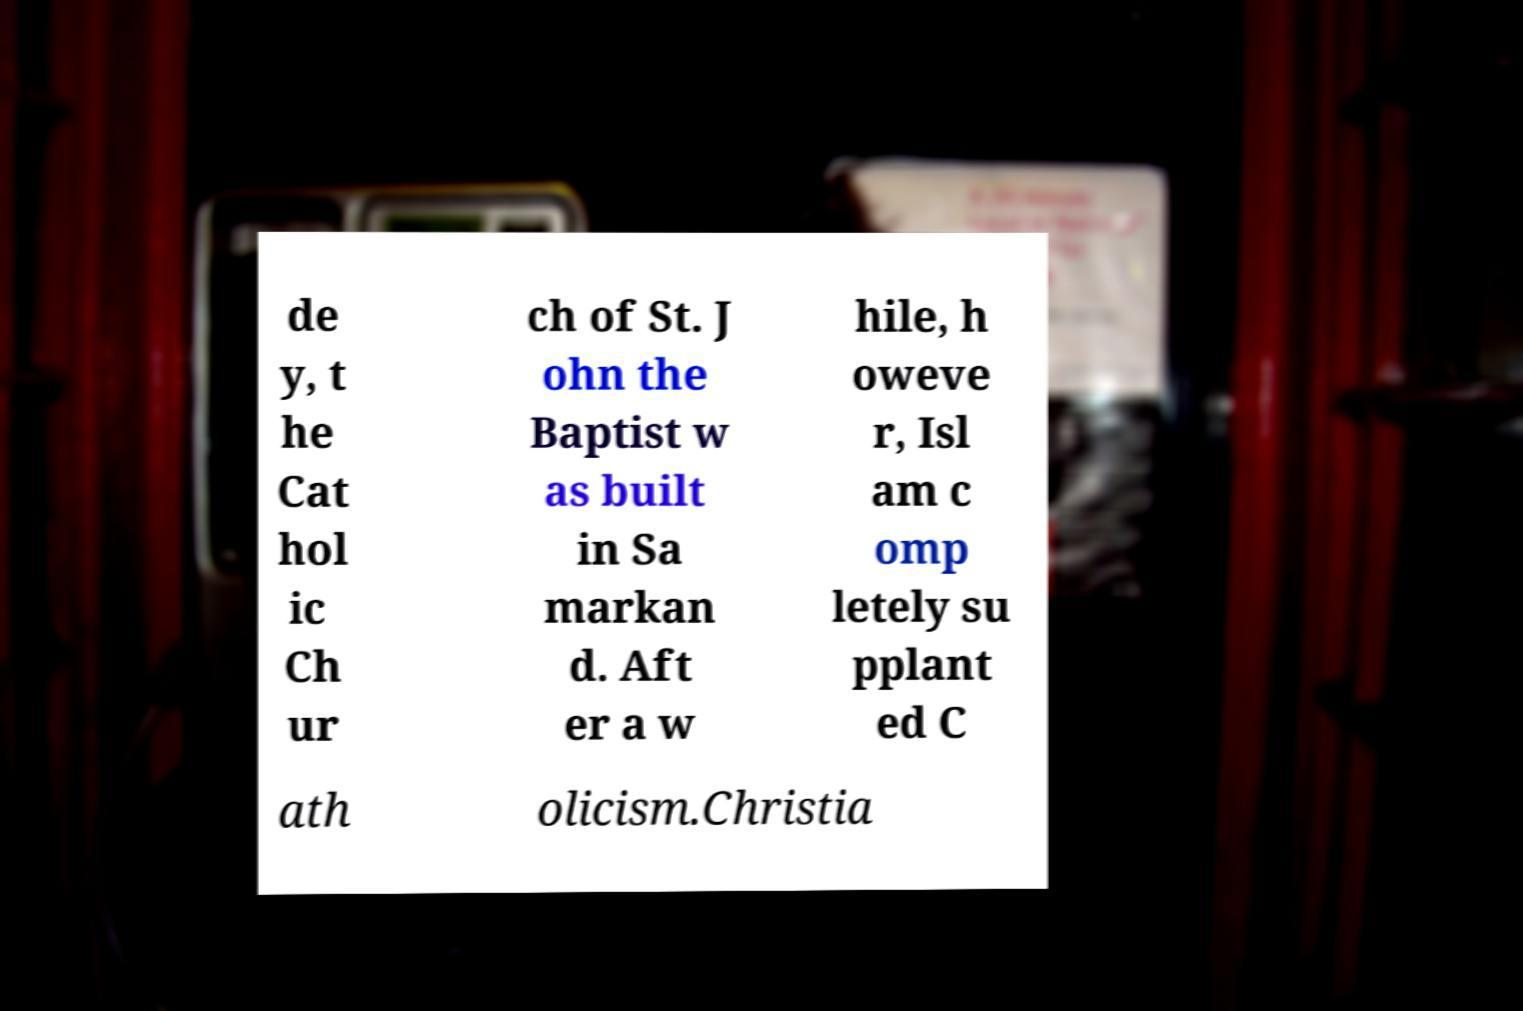There's text embedded in this image that I need extracted. Can you transcribe it verbatim? de y, t he Cat hol ic Ch ur ch of St. J ohn the Baptist w as built in Sa markan d. Aft er a w hile, h oweve r, Isl am c omp letely su pplant ed C ath olicism.Christia 